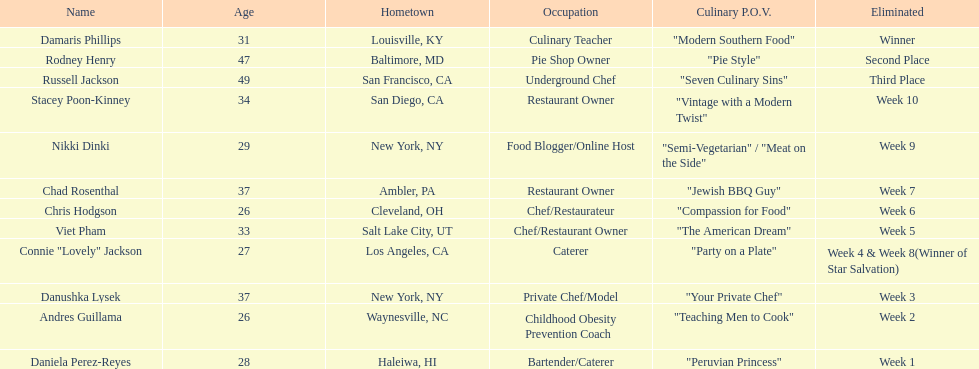Who are the participants in the competition? Damaris Phillips, Rodney Henry, Russell Jackson, Stacey Poon-Kinney, Nikki Dinki, Chad Rosenthal, Chris Hodgson, Viet Pham, Connie "Lovely" Jackson, Danushka Lysek, Andres Guillama, Daniela Perez-Reyes. What is the culinary perspective of each individual? "Modern Southern Food", "Pie Style", "Seven Culinary Sins", "Vintage with a Modern Twist", "Semi-Vegetarian" / "Meat on the Side", "Jewish BBQ Guy", "Compassion for Food", "The American Dream", "Party on a Plate", "Your Private Chef", "Teaching Men to Cook", "Peruvian Princess". And whose perspective is the most extensive? Nikki Dinki. 